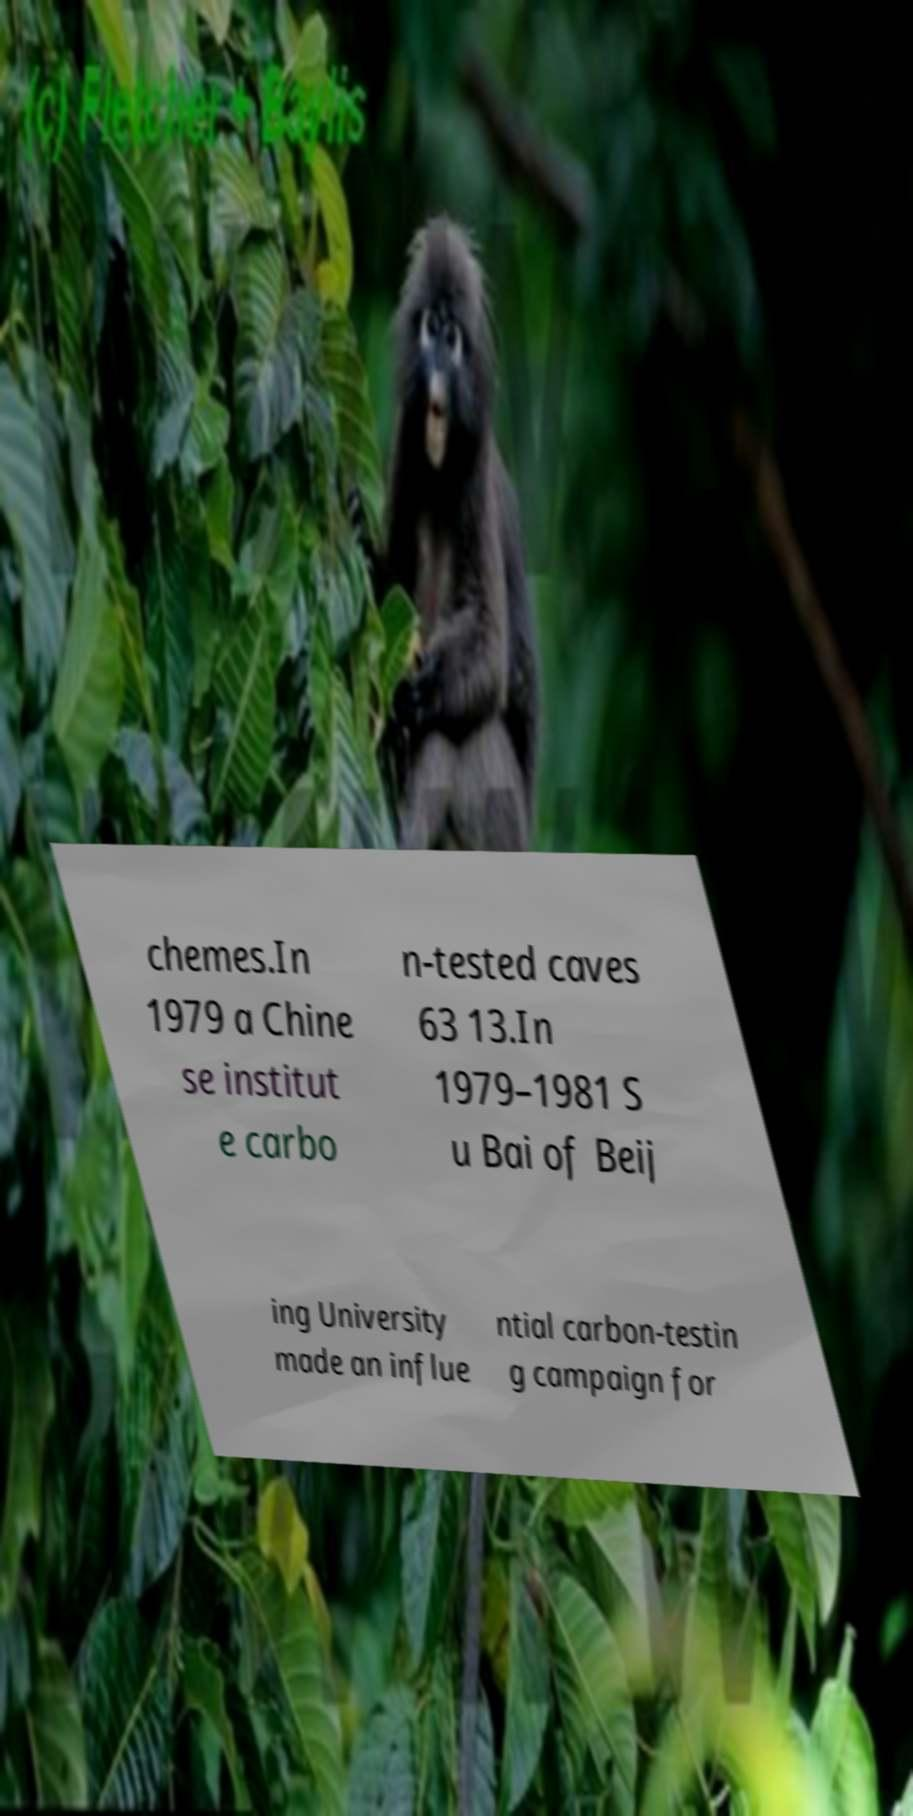There's text embedded in this image that I need extracted. Can you transcribe it verbatim? chemes.In 1979 a Chine se institut e carbo n-tested caves 63 13.In 1979–1981 S u Bai of Beij ing University made an influe ntial carbon-testin g campaign for 